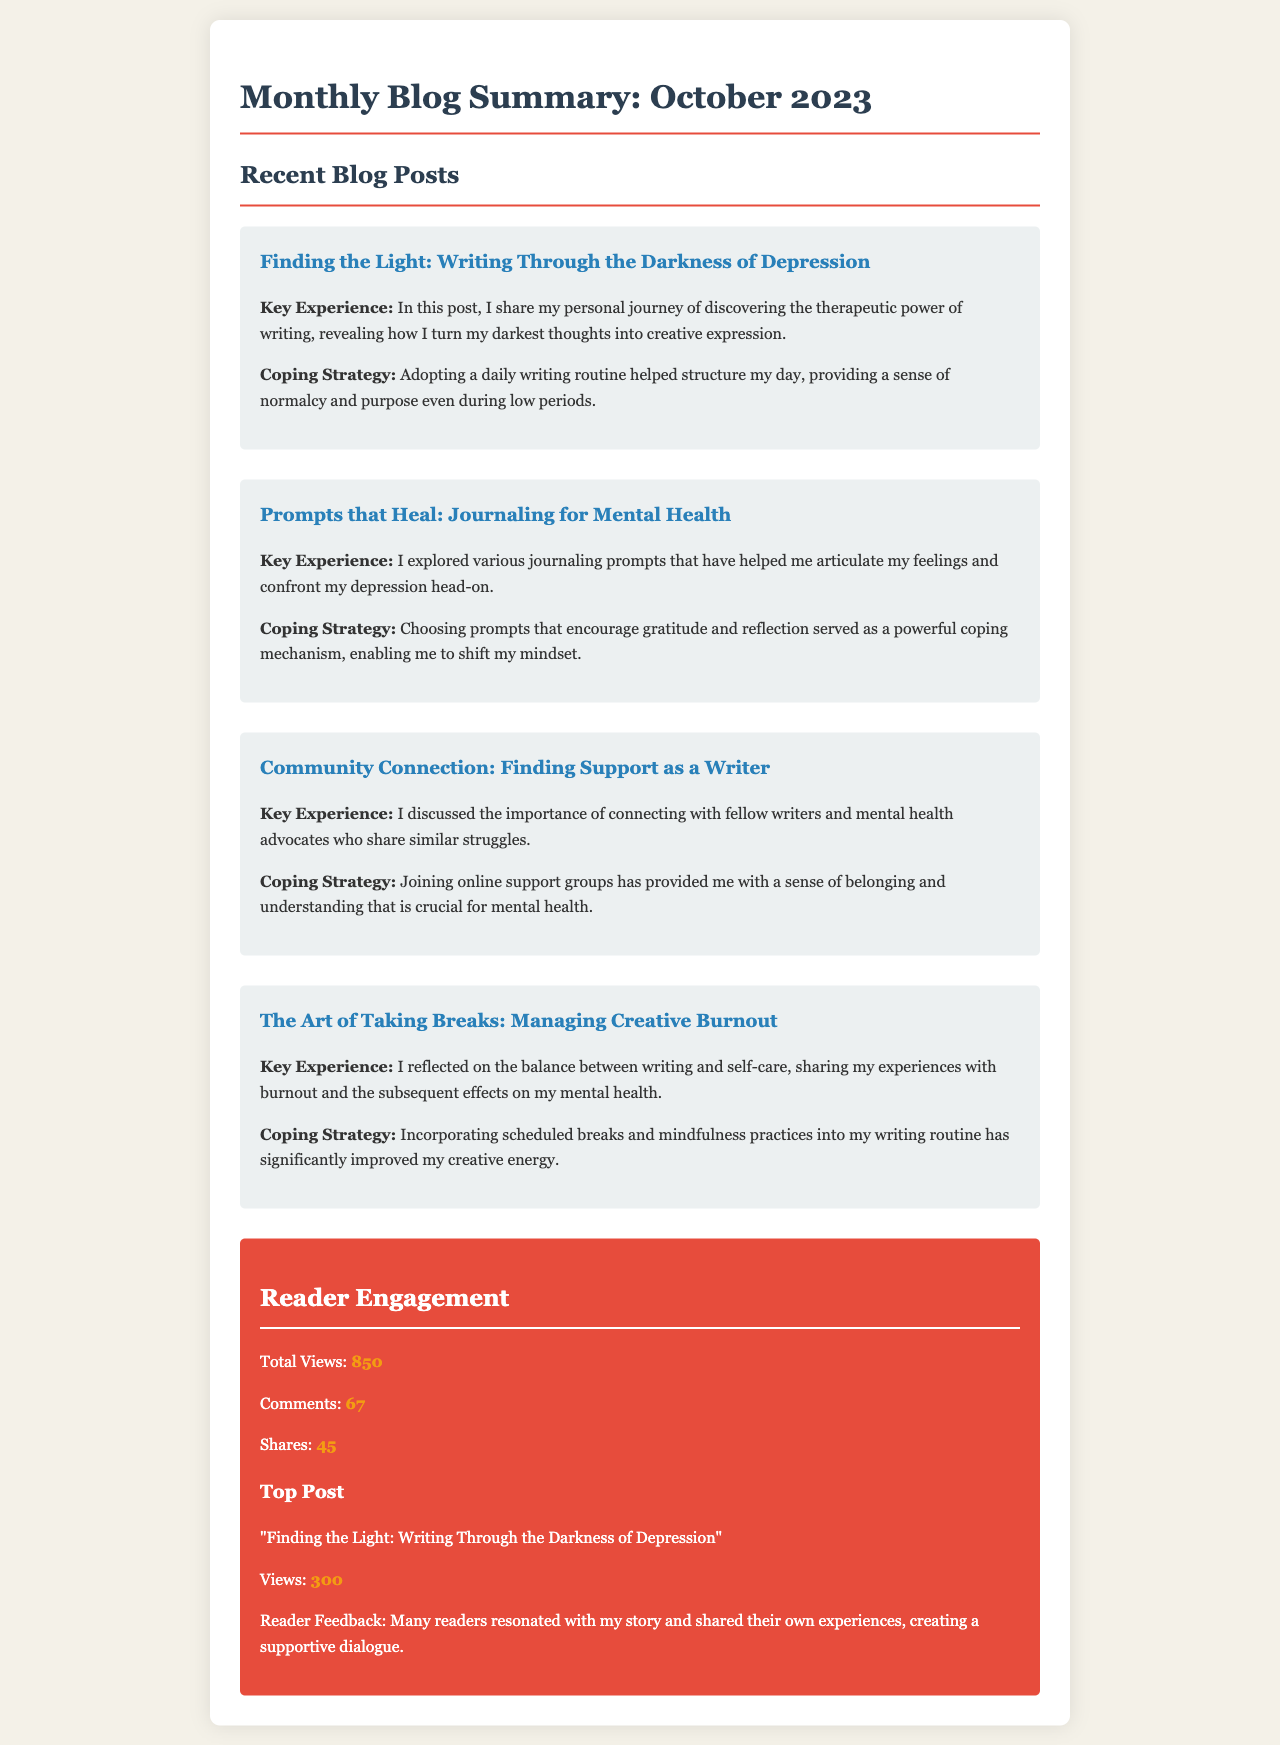what is the title of the blog summary? The title is provided at the beginning of the document, summarizing the monthly content.
Answer: Monthly Blog Summary: October 2023 how many total views were recorded? The total views are explicitly mentioned in the reader engagement section of the document.
Answer: 850 which blog post received the highest views? The document identifies the top-performing post based on view counts listed in the statistics.
Answer: Finding the Light: Writing Through the Darkness of Depression what coping strategy is mentioned for managing creative burnout? The document describes specific strategies used to cope with burnout, detailed in one of the blog posts.
Answer: Incorporating scheduled breaks and mindfulness practices how many comments were made on the blog posts? The number of comments is included in the reader engagement statistics section.
Answer: 67 what is one key experience shared in the post titled "Prompts that Heal: Journaling for Mental Health"? Each post includes a key experience that elaborates on the author's journey and reflections.
Answer: I explored various journaling prompts that have helped me articulate my feelings which post discusses connecting with fellow writers? The document specifies posts related to various subjects, including connection and community support.
Answer: Community Connection: Finding Support as a Writer how many shares were recorded for the blog posts? The document provides the total number of shares in the reader engagement statistics.
Answer: 45 what color is the background of the blog summary document? The document includes style descriptions, which detail the overall aesthetic choices made.
Answer: #f4f1e8 